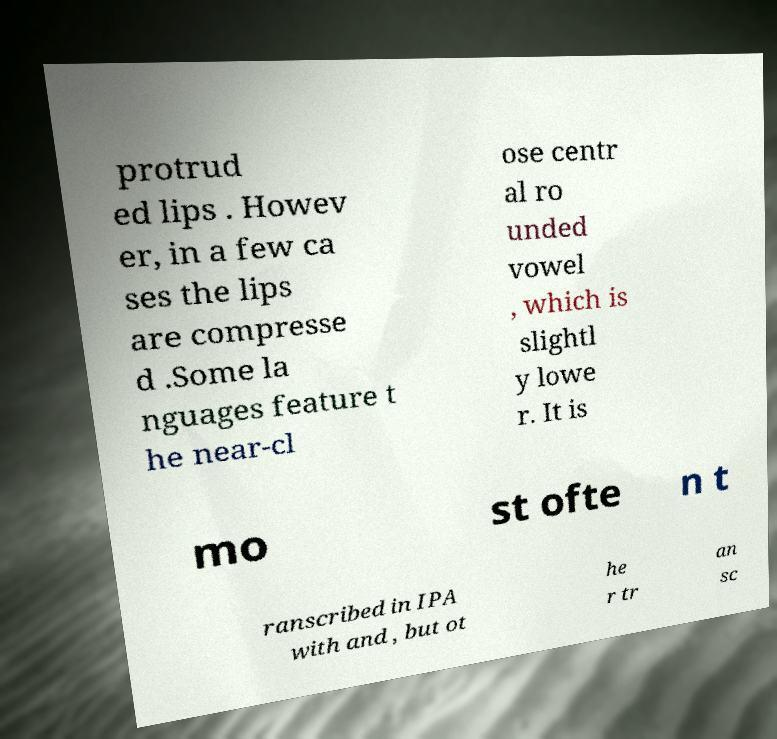Can you read and provide the text displayed in the image?This photo seems to have some interesting text. Can you extract and type it out for me? protrud ed lips . Howev er, in a few ca ses the lips are compresse d .Some la nguages feature t he near-cl ose centr al ro unded vowel , which is slightl y lowe r. It is mo st ofte n t ranscribed in IPA with and , but ot he r tr an sc 